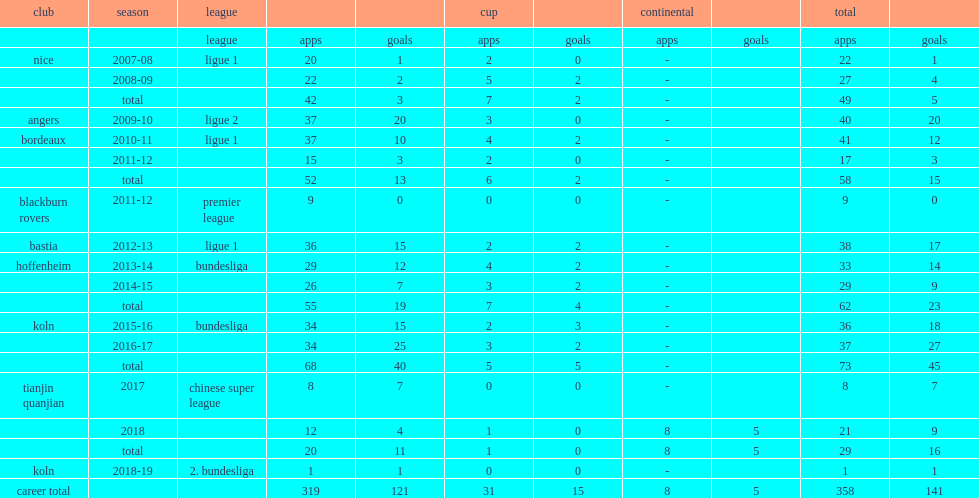Could you parse the entire table? {'header': ['club', 'season', 'league', '', '', 'cup', '', 'continental', '', 'total', ''], 'rows': [['', '', 'league', 'apps', 'goals', 'apps', 'goals', 'apps', 'goals', 'apps', 'goals'], ['nice', '2007-08', 'ligue 1', '20', '1', '2', '0', '-', '', '22', '1'], ['', '2008-09', '', '22', '2', '5', '2', '-', '', '27', '4'], ['', 'total', '', '42', '3', '7', '2', '-', '', '49', '5'], ['angers', '2009-10', 'ligue 2', '37', '20', '3', '0', '-', '', '40', '20'], ['bordeaux', '2010-11', 'ligue 1', '37', '10', '4', '2', '-', '', '41', '12'], ['', '2011-12', '', '15', '3', '2', '0', '-', '', '17', '3'], ['', 'total', '', '52', '13', '6', '2', '-', '', '58', '15'], ['blackburn rovers', '2011-12', 'premier league', '9', '0', '0', '0', '-', '', '9', '0'], ['bastia', '2012-13', 'ligue 1', '36', '15', '2', '2', '-', '', '38', '17'], ['hoffenheim', '2013-14', 'bundesliga', '29', '12', '4', '2', '-', '', '33', '14'], ['', '2014-15', '', '26', '7', '3', '2', '-', '', '29', '9'], ['', 'total', '', '55', '19', '7', '4', '-', '', '62', '23'], ['koln', '2015-16', 'bundesliga', '34', '15', '2', '3', '-', '', '36', '18'], ['', '2016-17', '', '34', '25', '3', '2', '-', '', '37', '27'], ['', 'total', '', '68', '40', '5', '5', '-', '', '73', '45'], ['tianjin quanjian', '2017', 'chinese super league', '8', '7', '0', '0', '-', '', '8', '7'], ['', '2018', '', '12', '4', '1', '0', '8', '5', '21', '9'], ['', 'total', '', '20', '11', '1', '0', '8', '5', '29', '16'], ['koln', '2018-19', '2. bundesliga', '1', '1', '0', '0', '-', '', '1', '1'], ['career total', '', '', '319', '121', '31', '15', '8', '5', '358', '141']]} Which club did modeste play for in 2017? Tianjin quanjian. 